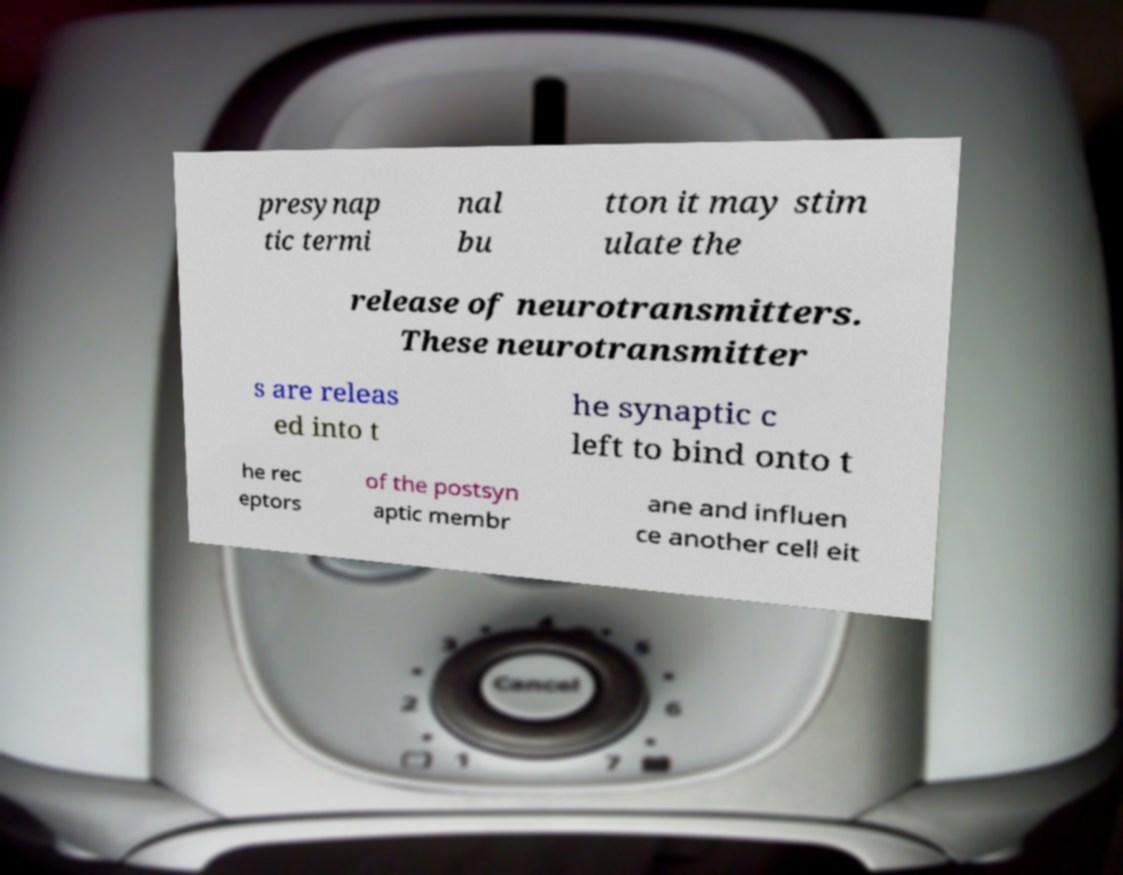What messages or text are displayed in this image? I need them in a readable, typed format. presynap tic termi nal bu tton it may stim ulate the release of neurotransmitters. These neurotransmitter s are releas ed into t he synaptic c left to bind onto t he rec eptors of the postsyn aptic membr ane and influen ce another cell eit 